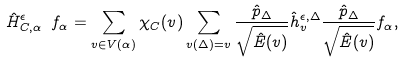Convert formula to latex. <formula><loc_0><loc_0><loc_500><loc_500>\hat { H } ^ { \epsilon } _ { C , \alpha } \ f _ { \alpha } = \sum _ { v \in V ( \alpha ) } \chi _ { C } ( v ) \sum _ { v ( \Delta ) = v } \frac { \hat { p } _ { \Delta } } { \sqrt { \hat { E } ( v ) } } \hat { h } ^ { \epsilon , \Delta } _ { v } \frac { \hat { p } _ { \Delta } } { \sqrt { \hat { E } ( v ) } } f _ { \alpha } ,</formula> 